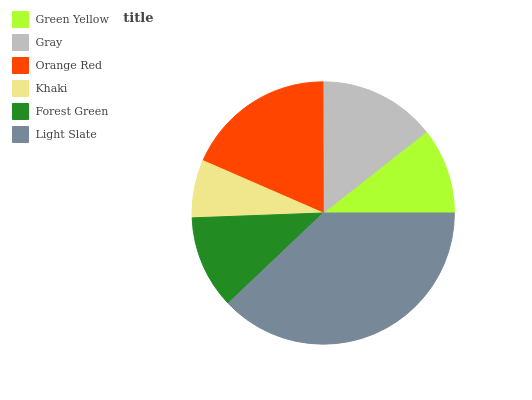Is Khaki the minimum?
Answer yes or no. Yes. Is Light Slate the maximum?
Answer yes or no. Yes. Is Gray the minimum?
Answer yes or no. No. Is Gray the maximum?
Answer yes or no. No. Is Gray greater than Green Yellow?
Answer yes or no. Yes. Is Green Yellow less than Gray?
Answer yes or no. Yes. Is Green Yellow greater than Gray?
Answer yes or no. No. Is Gray less than Green Yellow?
Answer yes or no. No. Is Gray the high median?
Answer yes or no. Yes. Is Forest Green the low median?
Answer yes or no. Yes. Is Orange Red the high median?
Answer yes or no. No. Is Gray the low median?
Answer yes or no. No. 